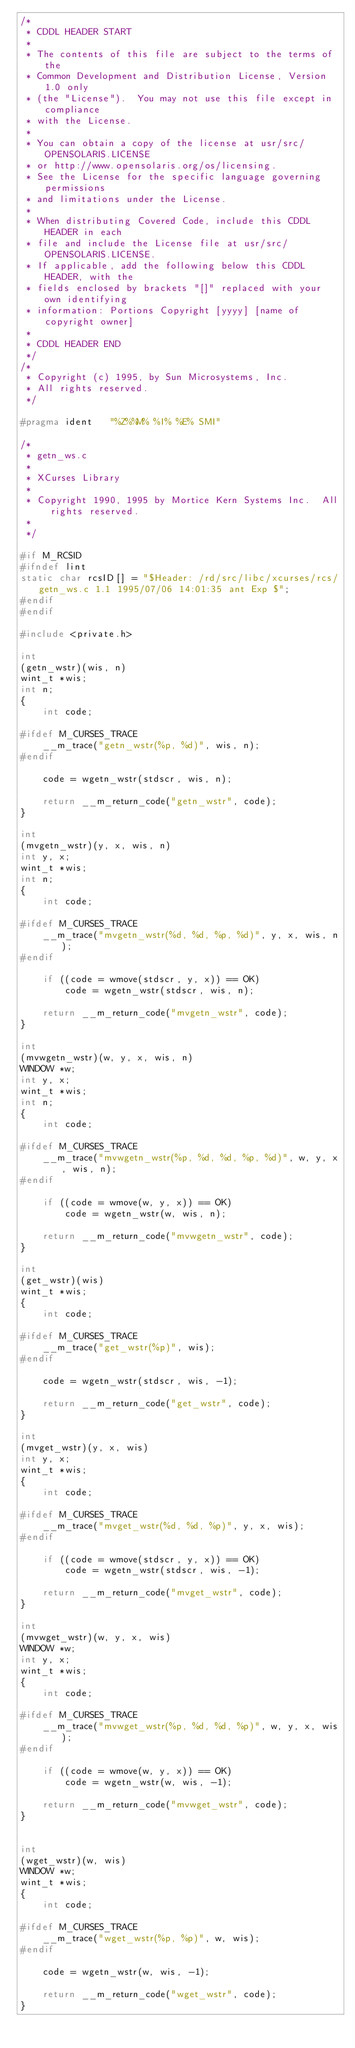Convert code to text. <code><loc_0><loc_0><loc_500><loc_500><_C_>/*
 * CDDL HEADER START
 *
 * The contents of this file are subject to the terms of the
 * Common Development and Distribution License, Version 1.0 only
 * (the "License").  You may not use this file except in compliance
 * with the License.
 *
 * You can obtain a copy of the license at usr/src/OPENSOLARIS.LICENSE
 * or http://www.opensolaris.org/os/licensing.
 * See the License for the specific language governing permissions
 * and limitations under the License.
 *
 * When distributing Covered Code, include this CDDL HEADER in each
 * file and include the License file at usr/src/OPENSOLARIS.LICENSE.
 * If applicable, add the following below this CDDL HEADER, with the
 * fields enclosed by brackets "[]" replaced with your own identifying
 * information: Portions Copyright [yyyy] [name of copyright owner]
 *
 * CDDL HEADER END
 */
/*
 * Copyright (c) 1995, by Sun Microsystems, Inc.
 * All rights reserved.
 */

#pragma ident	"%Z%%M%	%I%	%E% SMI"

/*
 * getn_ws.c
 * 
 * XCurses Library
 *
 * Copyright 1990, 1995 by Mortice Kern Systems Inc.  All rights reserved.
 *
 */

#if M_RCSID
#ifndef lint
static char rcsID[] = "$Header: /rd/src/libc/xcurses/rcs/getn_ws.c 1.1 1995/07/06 14:01:35 ant Exp $";
#endif
#endif

#include <private.h>

int
(getn_wstr)(wis, n)
wint_t *wis;
int n;
{
	int code;

#ifdef M_CURSES_TRACE
	__m_trace("getn_wstr(%p, %d)", wis, n);
#endif

	code = wgetn_wstr(stdscr, wis, n);

	return __m_return_code("getn_wstr", code);
}

int
(mvgetn_wstr)(y, x, wis, n)
int y, x;
wint_t *wis;
int n;
{
	int code;

#ifdef M_CURSES_TRACE
	__m_trace("mvgetn_wstr(%d, %d, %p, %d)", y, x, wis, n);
#endif

	if ((code = wmove(stdscr, y, x)) == OK)
		code = wgetn_wstr(stdscr, wis, n);

	return __m_return_code("mvgetn_wstr", code);
}

int
(mvwgetn_wstr)(w, y, x, wis, n)
WINDOW *w;
int y, x;
wint_t *wis;
int n;
{
	int code;

#ifdef M_CURSES_TRACE
	__m_trace("mvwgetn_wstr(%p, %d, %d, %p, %d)", w, y, x, wis, n);
#endif

	if ((code = wmove(w, y, x)) == OK)
		code = wgetn_wstr(w, wis, n);

	return __m_return_code("mvwgetn_wstr", code);
}

int
(get_wstr)(wis)
wint_t *wis;
{
	int code;

#ifdef M_CURSES_TRACE
	__m_trace("get_wstr(%p)", wis);
#endif

	code = wgetn_wstr(stdscr, wis, -1);

	return __m_return_code("get_wstr", code);
}

int
(mvget_wstr)(y, x, wis)
int y, x;
wint_t *wis;
{
	int code;

#ifdef M_CURSES_TRACE
	__m_trace("mvget_wstr(%d, %d, %p)", y, x, wis);
#endif

	if ((code = wmove(stdscr, y, x)) == OK)
		code = wgetn_wstr(stdscr, wis, -1);

	return __m_return_code("mvget_wstr", code);
}

int
(mvwget_wstr)(w, y, x, wis)
WINDOW *w;
int y, x;
wint_t *wis;
{
	int code;

#ifdef M_CURSES_TRACE
	__m_trace("mvwget_wstr(%p, %d, %d, %p)", w, y, x, wis);
#endif

	if ((code = wmove(w, y, x)) == OK)
		code = wgetn_wstr(w, wis, -1);

	return __m_return_code("mvwget_wstr", code);
}


int
(wget_wstr)(w, wis)
WINDOW *w;
wint_t *wis;
{
	int code;

#ifdef M_CURSES_TRACE
	__m_trace("wget_wstr(%p, %p)", w, wis);
#endif

	code = wgetn_wstr(w, wis, -1);

	return __m_return_code("wget_wstr", code);
}

</code> 